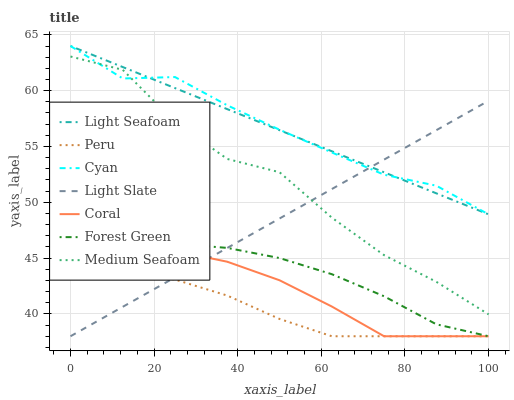Does Peru have the minimum area under the curve?
Answer yes or no. Yes. Does Cyan have the maximum area under the curve?
Answer yes or no. Yes. Does Coral have the minimum area under the curve?
Answer yes or no. No. Does Coral have the maximum area under the curve?
Answer yes or no. No. Is Light Seafoam the smoothest?
Answer yes or no. Yes. Is Medium Seafoam the roughest?
Answer yes or no. Yes. Is Coral the smoothest?
Answer yes or no. No. Is Coral the roughest?
Answer yes or no. No. Does Cyan have the lowest value?
Answer yes or no. No. Does Coral have the highest value?
Answer yes or no. No. Is Peru less than Medium Seafoam?
Answer yes or no. Yes. Is Medium Seafoam greater than Peru?
Answer yes or no. Yes. Does Peru intersect Medium Seafoam?
Answer yes or no. No. 